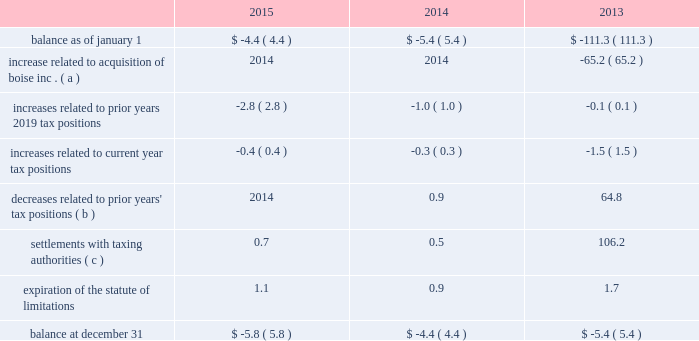Cash payments for federal , state , and foreign income taxes were $ 238.3 million , $ 189.5 million , and $ 90.7 million for the years ended december 31 , 2015 , 2014 , and 2013 , respectively .
The table summarizes the changes related to pca 2019s gross unrecognized tax benefits excluding interest and penalties ( dollars in millions ) : .
( a ) in 2013 , pca acquired $ 65.2 million of gross unrecognized tax benefits from boise inc .
That related primarily to the taxability of the alternative energy tax credits .
( b ) the 2013 amount includes a $ 64.3 million gross decrease related to the taxability of the alternative energy tax credits claimed in 2009 excise tax returns by boise inc .
For further discussion regarding these credits , see note 7 , alternative energy tax credits .
( c ) the 2013 amount includes a $ 104.7 million gross decrease related to the conclusion of the internal revenue service audit of pca 2019s alternative energy tax credits .
For further discussion regarding these credits , see note 7 , alternative energy tax credits .
At december 31 , 2015 , pca had recorded a $ 5.8 million gross reserve for unrecognized tax benefits , excluding interest and penalties .
Of the total , $ 4.2 million ( net of the federal benefit for state taxes ) would impact the effective tax rate if recognized .
Pca recognizes interest accrued related to unrecognized tax benefits and penalties as income tax expense .
At december 31 , 2015 and 2014 , we had an insignificant amount of interest and penalties recorded for unrecognized tax benefits included in the table above .
Pca does not expect the unrecognized tax benefits to change significantly over the next 12 months .
Pca is subject to taxation in the united states and various state and foreign jurisdictions .
A federal examination of the tax years 2010 2014 2012 was concluded in february 2015 .
A federal examination of the 2013 tax year began in october 2015 .
The tax years 2014 2014 2015 remain open to federal examination .
The tax years 2011 2014 2015 remain open to state examinations .
Some foreign tax jurisdictions are open to examination for the 2008 tax year forward .
Through the boise acquisition , pca recorded net operating losses and credit carryforwards from 2008 through 2011 and 2013 that are subject to examinations and adjustments for at least three years following the year in which utilized .
Alternative energy tax credits the company generates black liquor as a by-product of its pulp manufacturing process , which entitled it to certain federal income tax credits .
When black liquor is mixed with diesel , it is considered an alternative fuel that was eligible for a $ 0.50 per gallon refundable alternative energy tax credit for gallons produced before december 31 , 2009 .
Black liquor was also eligible for a $ 1.01 per gallon taxable cellulosic biofuel producer credit for gallons of black liquor produced and used in 2009 .
In 2013 , we reversed $ 166.0 million of a reserve for unrecognized tax benefits for alternative energy tax credits as a benefit to income taxes .
Approximately $ 103.9 million ( $ 102.0 million of tax , net of the federal benefit for state taxes , plus $ 1.9 million of accrued interest ) of the reversal is due to the completion of the irs .
What was the difference in millions of cash payments for federal , state , and foreign income taxes between 2014 and 2015? 
Computations: (238.3 - 189.5)
Answer: 48.8. 